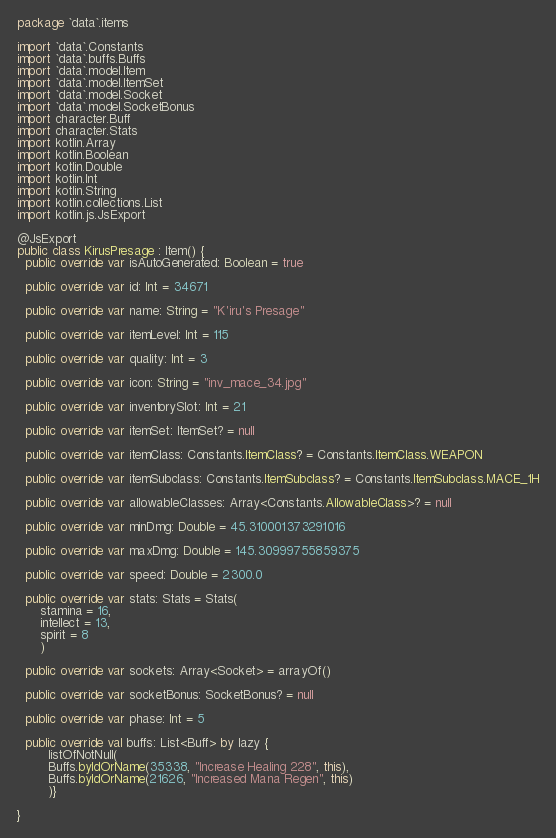Convert code to text. <code><loc_0><loc_0><loc_500><loc_500><_Kotlin_>package `data`.items

import `data`.Constants
import `data`.buffs.Buffs
import `data`.model.Item
import `data`.model.ItemSet
import `data`.model.Socket
import `data`.model.SocketBonus
import character.Buff
import character.Stats
import kotlin.Array
import kotlin.Boolean
import kotlin.Double
import kotlin.Int
import kotlin.String
import kotlin.collections.List
import kotlin.js.JsExport

@JsExport
public class KirusPresage : Item() {
  public override var isAutoGenerated: Boolean = true

  public override var id: Int = 34671

  public override var name: String = "K'iru's Presage"

  public override var itemLevel: Int = 115

  public override var quality: Int = 3

  public override var icon: String = "inv_mace_34.jpg"

  public override var inventorySlot: Int = 21

  public override var itemSet: ItemSet? = null

  public override var itemClass: Constants.ItemClass? = Constants.ItemClass.WEAPON

  public override var itemSubclass: Constants.ItemSubclass? = Constants.ItemSubclass.MACE_1H

  public override var allowableClasses: Array<Constants.AllowableClass>? = null

  public override var minDmg: Double = 45.310001373291016

  public override var maxDmg: Double = 145.30999755859375

  public override var speed: Double = 2300.0

  public override var stats: Stats = Stats(
      stamina = 16,
      intellect = 13,
      spirit = 8
      )

  public override var sockets: Array<Socket> = arrayOf()

  public override var socketBonus: SocketBonus? = null

  public override var phase: Int = 5

  public override val buffs: List<Buff> by lazy {
        listOfNotNull(
        Buffs.byIdOrName(35338, "Increase Healing 228", this),
        Buffs.byIdOrName(21626, "Increased Mana Regen", this)
        )}

}
</code> 